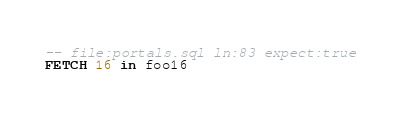<code> <loc_0><loc_0><loc_500><loc_500><_SQL_>-- file:portals.sql ln:83 expect:true
FETCH 16 in foo16
</code> 